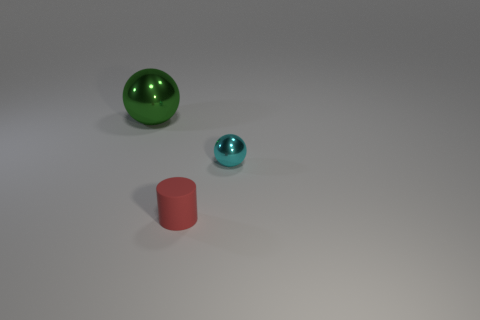Add 3 large things. How many objects exist? 6 Subtract all cylinders. How many objects are left? 2 Add 3 large red rubber cylinders. How many large red rubber cylinders exist? 3 Subtract 0 blue cubes. How many objects are left? 3 Subtract all big objects. Subtract all large gray shiny cylinders. How many objects are left? 2 Add 3 tiny metallic things. How many tiny metallic things are left? 4 